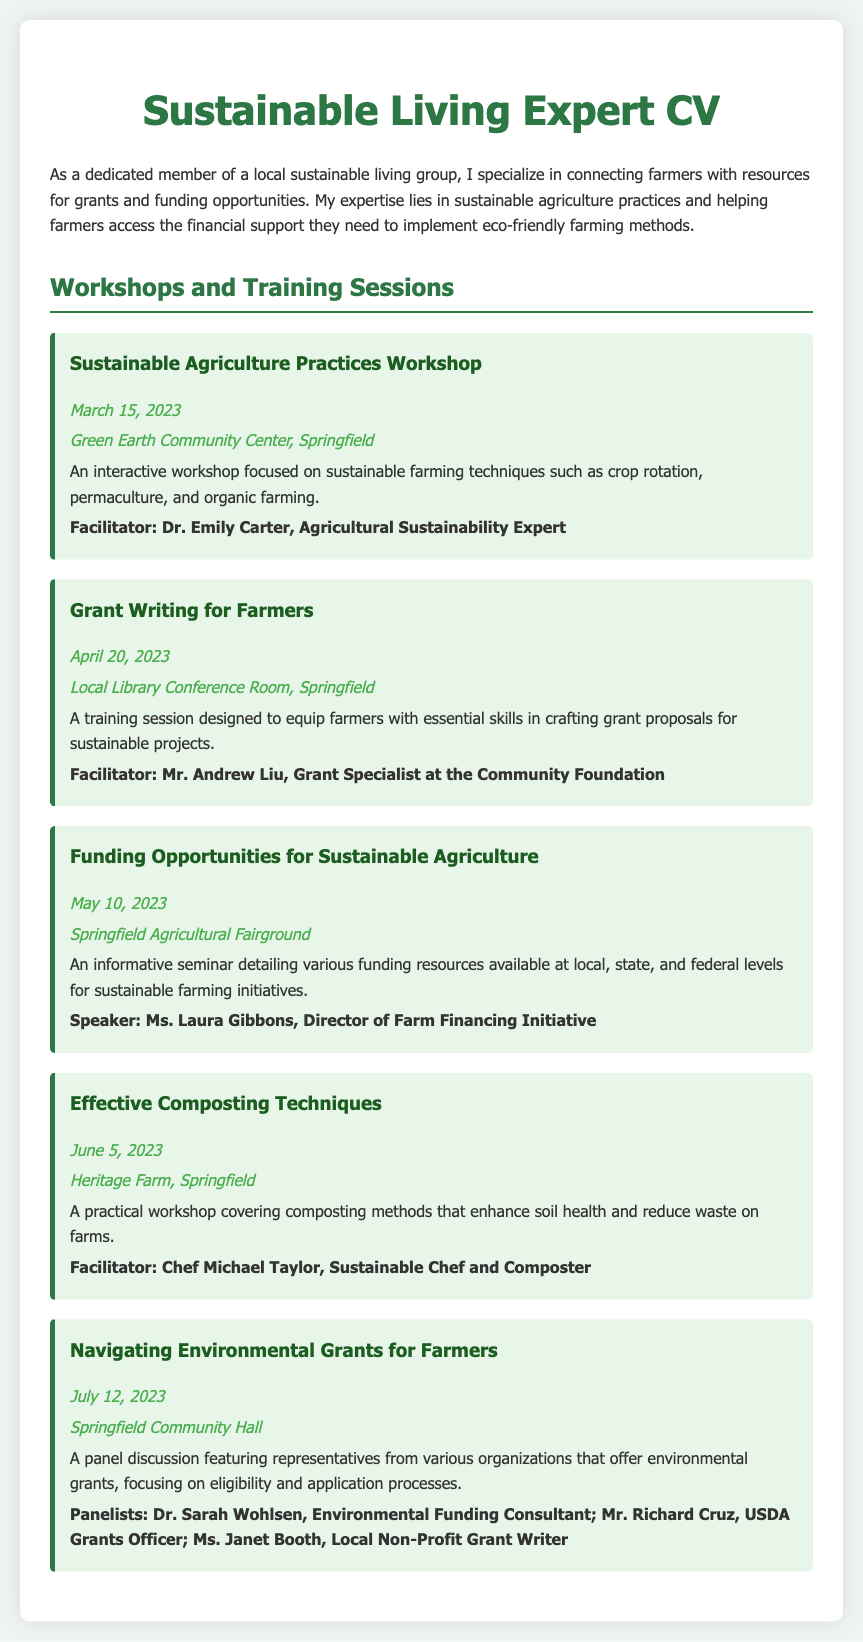what is the title of the first workshop? The title of the first workshop is clearly stated in the document under the "Workshops and Training Sessions" section.
Answer: Sustainable Agriculture Practices Workshop who was the facilitator of the "Grant Writing for Farmers" session? The facilitator's name can be found in the details of the "Grant Writing for Farmers" workshop listed in the document.
Answer: Mr. Andrew Liu when was the "Funding Opportunities for Sustainable Agriculture" seminar held? The date for the seminar is explicitly mentioned in its description within the document.
Answer: May 10, 2023 what location hosted the "Effective Composting Techniques" workshop? The location is provided in the details of the "Effective Composting Techniques" workshop in the document.
Answer: Heritage Farm, Springfield which workshop had a panel discussion format? This information is derived from the description of the "Navigating Environmental Grants for Farmers" workshop, which mentions a panel discussion.
Answer: Navigating Environmental Grants for Farmers how many workshops and training sessions are listed in the document? The number can be calculated based on the workshops provided in the "Workshops and Training Sessions" section of the document.
Answer: Five who is the speaker for the "Funding Opportunities for Sustainable Agriculture" seminar? The speaker's name is mentioned in the details of the "Funding Opportunities for Sustainable Agriculture" seminar.
Answer: Ms. Laura Gibbons what is the main topic of the "Sustainable Agriculture Practices Workshop"? The main topic is described in the overview of that workshop within the document.
Answer: Sustainable farming techniques what was the date of the last workshop mentioned? The date of the last workshop can be found in the details of the "Navigating Environmental Grants for Farmers" workshop in the document.
Answer: July 12, 2023 